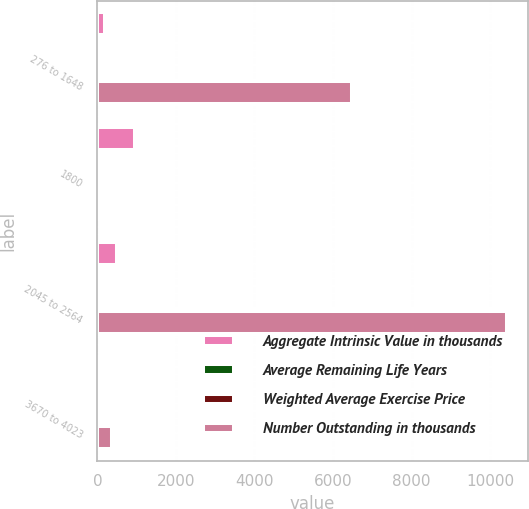<chart> <loc_0><loc_0><loc_500><loc_500><stacked_bar_chart><ecel><fcel>276 to 1648<fcel>1800<fcel>2045 to 2564<fcel>3670 to 4023<nl><fcel>Aggregate Intrinsic Value in thousands<fcel>204<fcel>961<fcel>509<fcel>55<nl><fcel>Average Remaining Life Years<fcel>11.95<fcel>18<fcel>23.23<fcel>36.7<nl><fcel>Weighted Average Exercise Price<fcel>3.2<fcel>3.86<fcel>4.32<fcel>6.95<nl><fcel>Number Outstanding in thousands<fcel>6481<fcel>36.7<fcel>10433<fcel>385<nl></chart> 